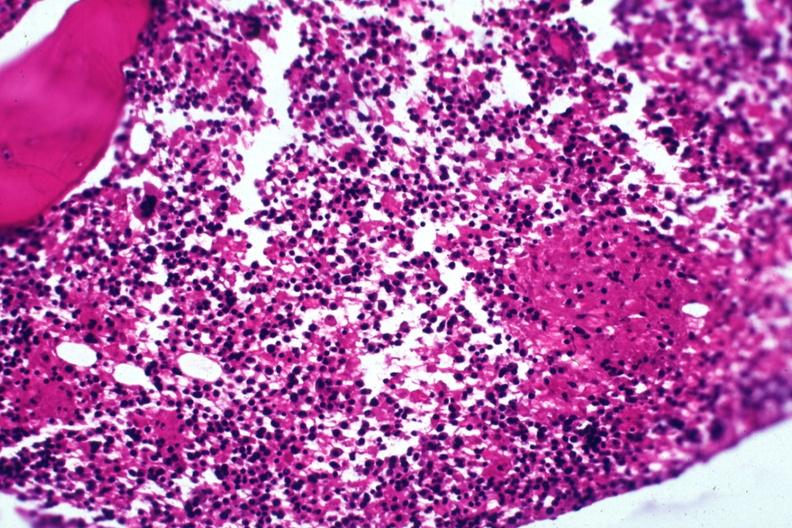s supernumerary digit present?
Answer the question using a single word or phrase. No 